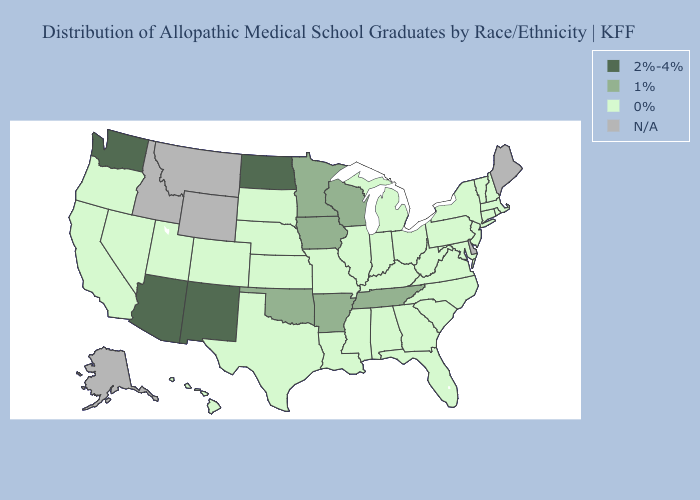Among the states that border Missouri , which have the lowest value?
Be succinct. Illinois, Kansas, Kentucky, Nebraska. What is the value of Georgia?
Answer briefly. 0%. Does Georgia have the lowest value in the South?
Short answer required. Yes. What is the lowest value in the Northeast?
Answer briefly. 0%. Is the legend a continuous bar?
Give a very brief answer. No. Name the states that have a value in the range N/A?
Be succinct. Alaska, Delaware, Idaho, Maine, Montana, Wyoming. Does Iowa have the highest value in the MidWest?
Short answer required. No. What is the highest value in the South ?
Concise answer only. 1%. Name the states that have a value in the range N/A?
Write a very short answer. Alaska, Delaware, Idaho, Maine, Montana, Wyoming. Which states have the lowest value in the USA?
Write a very short answer. Alabama, California, Colorado, Connecticut, Florida, Georgia, Hawaii, Illinois, Indiana, Kansas, Kentucky, Louisiana, Maryland, Massachusetts, Michigan, Mississippi, Missouri, Nebraska, Nevada, New Hampshire, New Jersey, New York, North Carolina, Ohio, Oregon, Pennsylvania, Rhode Island, South Carolina, South Dakota, Texas, Utah, Vermont, Virginia, West Virginia. Which states have the highest value in the USA?
Be succinct. Arizona, New Mexico, North Dakota, Washington. Which states have the lowest value in the South?
Answer briefly. Alabama, Florida, Georgia, Kentucky, Louisiana, Maryland, Mississippi, North Carolina, South Carolina, Texas, Virginia, West Virginia. What is the highest value in the USA?
Short answer required. 2%-4%. What is the lowest value in the MidWest?
Concise answer only. 0%. 